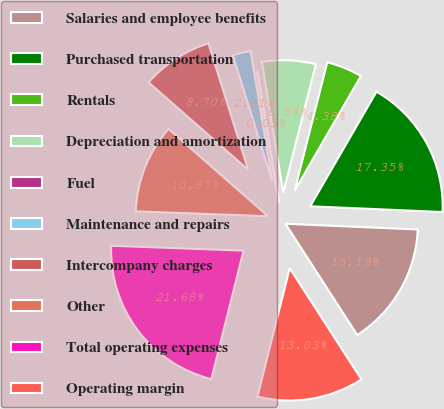Convert chart to OTSL. <chart><loc_0><loc_0><loc_500><loc_500><pie_chart><fcel>Salaries and employee benefits<fcel>Purchased transportation<fcel>Rentals<fcel>Depreciation and amortization<fcel>Fuel<fcel>Maintenance and repairs<fcel>Intercompany charges<fcel>Other<fcel>Total operating expenses<fcel>Operating margin<nl><fcel>15.19%<fcel>17.35%<fcel>4.38%<fcel>6.54%<fcel>0.05%<fcel>2.21%<fcel>8.7%<fcel>10.87%<fcel>21.68%<fcel>13.03%<nl></chart> 